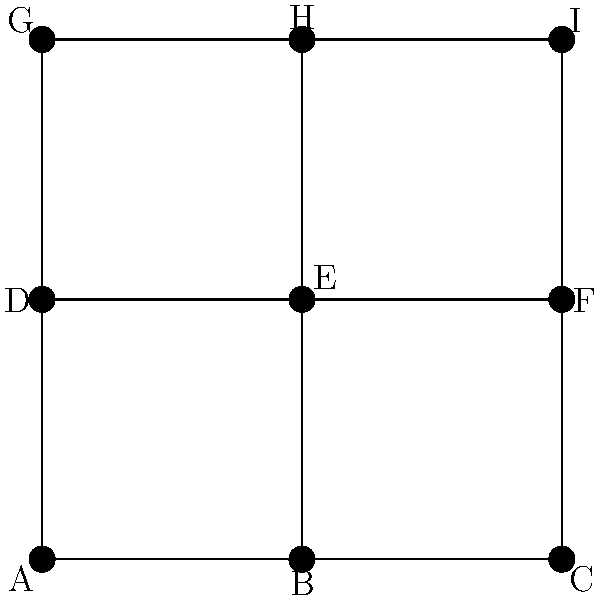As an editor of an architectural magazine, you're reviewing an article about a historic town center's layout. The simplified map above represents the town's main intersections and streets. What is the minimum number of streets that need to be traversed to visit all intersections exactly once, starting and ending at the same intersection? To solve this problem, we need to apply the concept of Eulerian circuits in graph theory. Here's a step-by-step approach:

1. First, we need to count the degree (number of connecting streets) of each intersection:
   A: 3, B: 3, C: 2, D: 3, E: 4, F: 3, G: 2, H: 3, I: 2

2. For an Eulerian circuit to exist (which would be the optimal solution), all vertices must have an even degree. In this case, we have odd degrees, so a perfect Eulerian circuit is not possible.

3. The next best solution is to find an Eulerian path with two odd-degree vertices (start and end points). However, we have more than two odd-degree vertices.

4. To solve this, we need to add the minimum number of edges to make all vertices even-degree except two. This can be done by adding 1 edge:
   - Connect C to G (or C to I, or G to I)

5. After adding this edge, we have an Eulerian path. The number of edges in this path will be the original number of edges plus the added edge.

6. Count the original edges: 12 (each line segment represents one edge)

7. Total edges in the Eulerian path: 12 + 1 = 13

Therefore, the minimum number of streets to traverse all intersections once, starting and ending at the same point, is 13.
Answer: 13 streets 